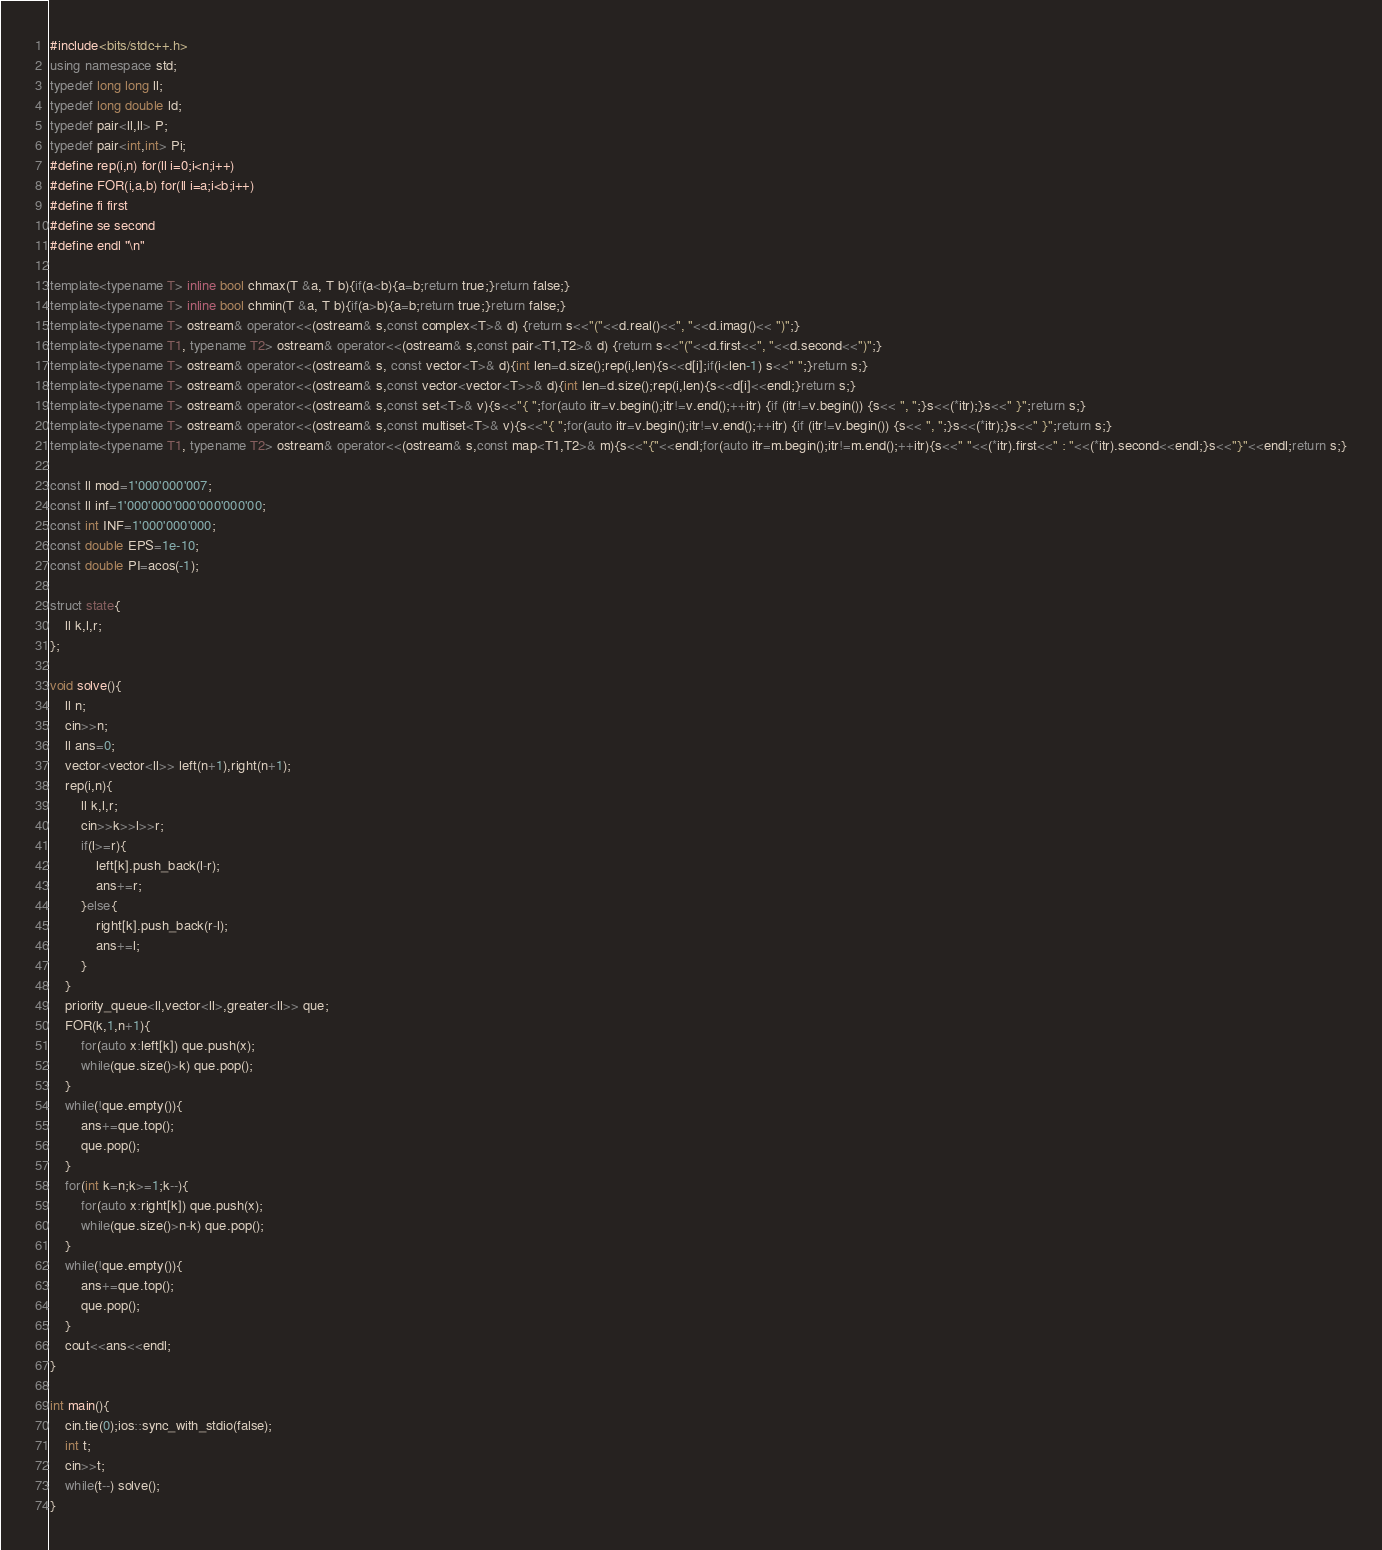Convert code to text. <code><loc_0><loc_0><loc_500><loc_500><_C++_>#include<bits/stdc++.h>
using namespace std;
typedef long long ll;
typedef long double ld;
typedef pair<ll,ll> P;
typedef pair<int,int> Pi;
#define rep(i,n) for(ll i=0;i<n;i++)
#define FOR(i,a,b) for(ll i=a;i<b;i++)
#define fi first
#define se second
#define endl "\n"

template<typename T> inline bool chmax(T &a, T b){if(a<b){a=b;return true;}return false;}
template<typename T> inline bool chmin(T &a, T b){if(a>b){a=b;return true;}return false;}
template<typename T> ostream& operator<<(ostream& s,const complex<T>& d) {return s<<"("<<d.real()<<", "<<d.imag()<< ")";}
template<typename T1, typename T2> ostream& operator<<(ostream& s,const pair<T1,T2>& d) {return s<<"("<<d.first<<", "<<d.second<<")";}
template<typename T> ostream& operator<<(ostream& s, const vector<T>& d){int len=d.size();rep(i,len){s<<d[i];if(i<len-1) s<<" ";}return s;}
template<typename T> ostream& operator<<(ostream& s,const vector<vector<T>>& d){int len=d.size();rep(i,len){s<<d[i]<<endl;}return s;}
template<typename T> ostream& operator<<(ostream& s,const set<T>& v){s<<"{ ";for(auto itr=v.begin();itr!=v.end();++itr) {if (itr!=v.begin()) {s<< ", ";}s<<(*itr);}s<<" }";return s;}
template<typename T> ostream& operator<<(ostream& s,const multiset<T>& v){s<<"{ ";for(auto itr=v.begin();itr!=v.end();++itr) {if (itr!=v.begin()) {s<< ", ";}s<<(*itr);}s<<" }";return s;}
template<typename T1, typename T2> ostream& operator<<(ostream& s,const map<T1,T2>& m){s<<"{"<<endl;for(auto itr=m.begin();itr!=m.end();++itr){s<<" "<<(*itr).first<<" : "<<(*itr).second<<endl;}s<<"}"<<endl;return s;}

const ll mod=1'000'000'007;
const ll inf=1'000'000'000'000'000'00;
const int INF=1'000'000'000;
const double EPS=1e-10;
const double PI=acos(-1);

struct state{
    ll k,l,r;
};

void solve(){
    ll n;
    cin>>n;
    ll ans=0;
    vector<vector<ll>> left(n+1),right(n+1);
    rep(i,n){
        ll k,l,r;
        cin>>k>>l>>r;
        if(l>=r){
            left[k].push_back(l-r);
            ans+=r;
        }else{
            right[k].push_back(r-l);
            ans+=l;
        }
    }
    priority_queue<ll,vector<ll>,greater<ll>> que;
    FOR(k,1,n+1){
        for(auto x:left[k]) que.push(x);
        while(que.size()>k) que.pop();
    }
    while(!que.empty()){
        ans+=que.top();
        que.pop();
    }
    for(int k=n;k>=1;k--){
        for(auto x:right[k]) que.push(x);
        while(que.size()>n-k) que.pop();
    }
    while(!que.empty()){
        ans+=que.top();
        que.pop();
    }
    cout<<ans<<endl;
}

int main(){
    cin.tie(0);ios::sync_with_stdio(false);
    int t;
    cin>>t;
    while(t--) solve();
}</code> 